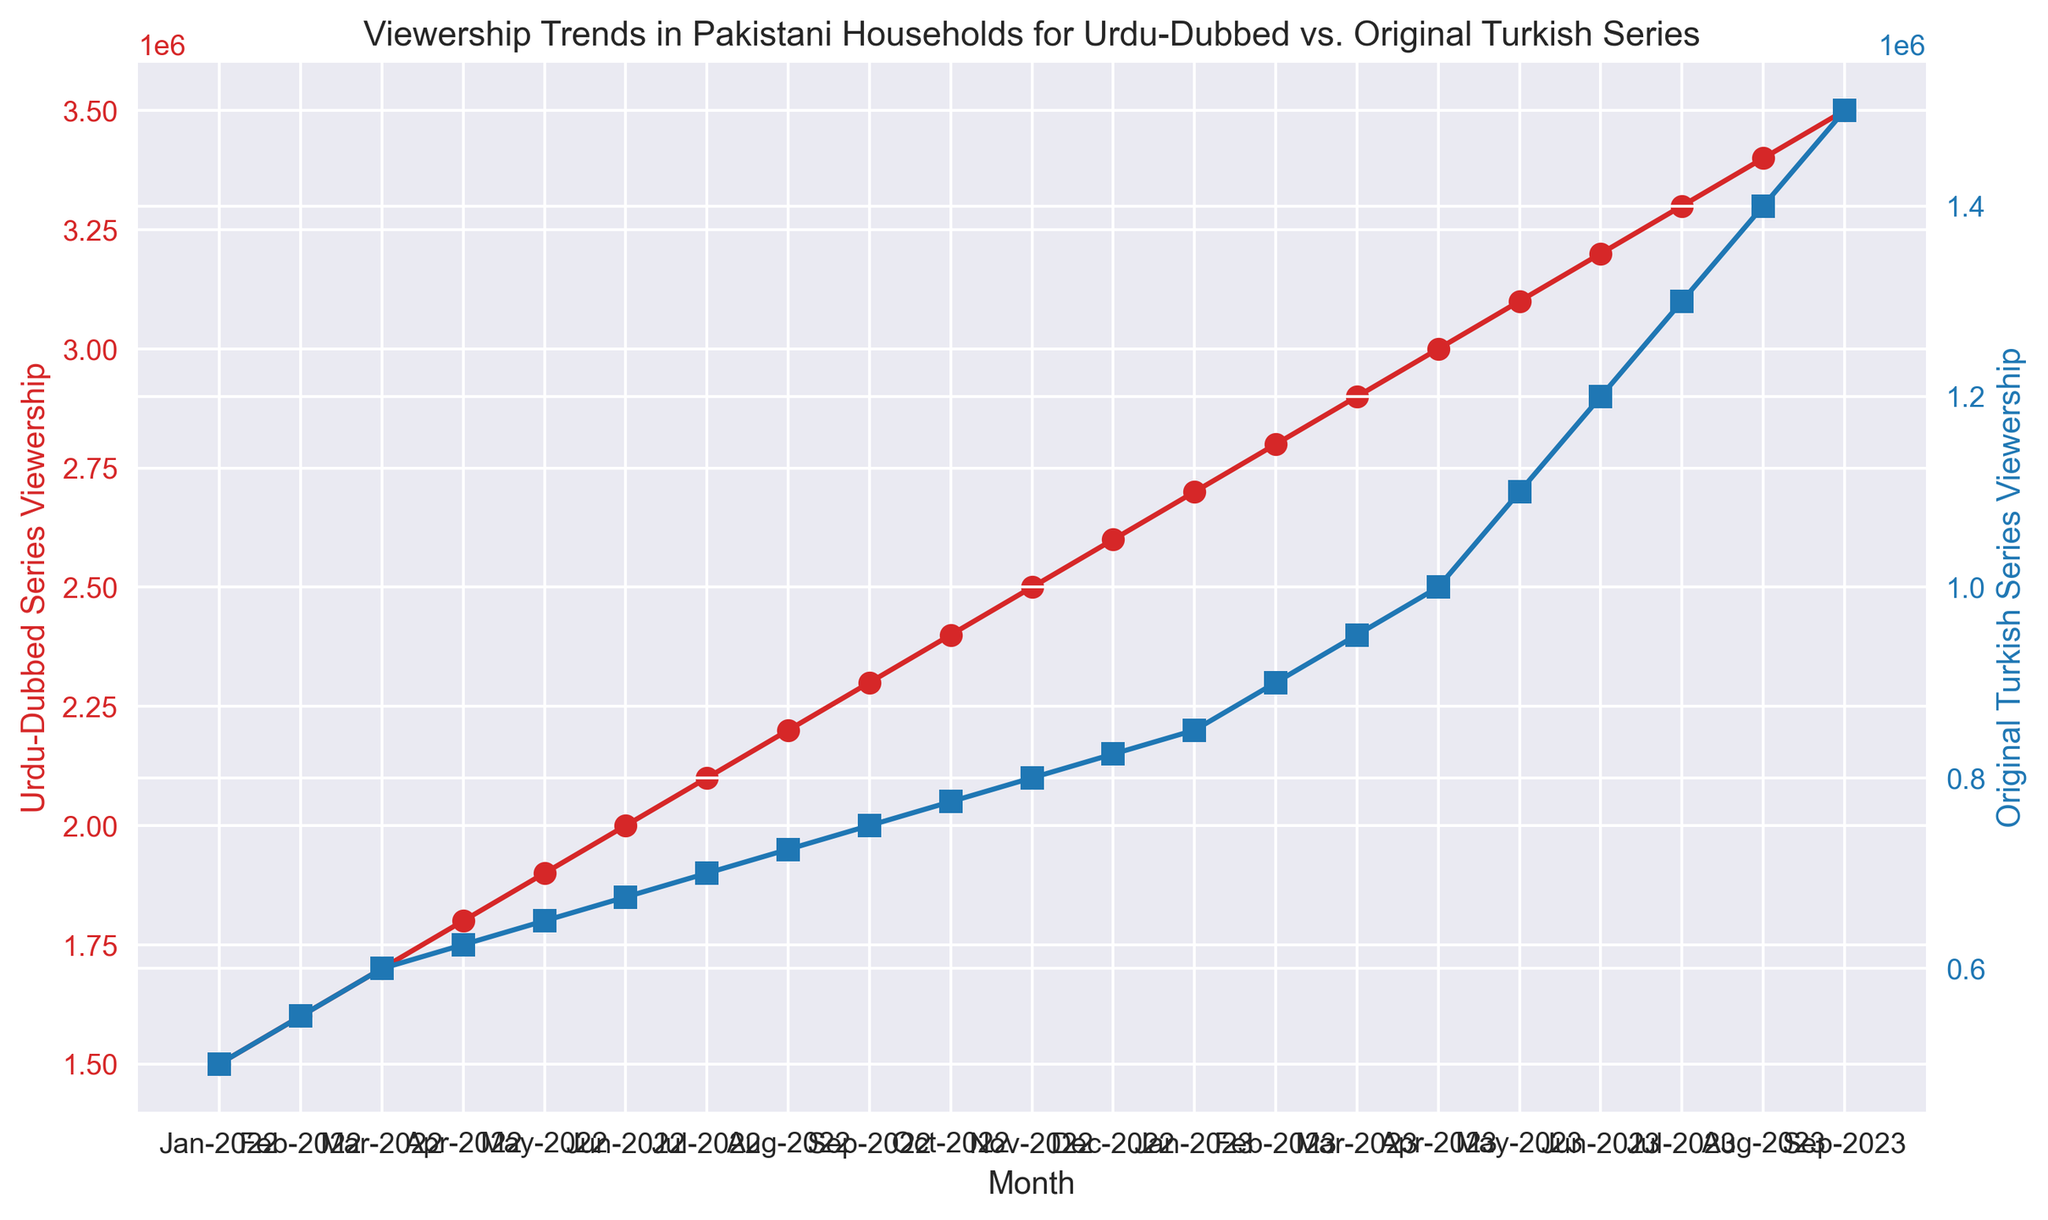Which month in 2022 had the highest viewership for Urdu-Dubbed Series? To find the month with the highest viewership for Urdu-Dubbed Series in 2022, we look at the data points from January 2022 to December 2022. December 2022 has the highest viewership with 2,600,000.
Answer: December 2022 In which month(s) does the Original Turkish Series viewership reach 1,000,000 or more? To determine the month(s) when the Original Turkish Series viewership reaches 1,000,000 or more, observe the data points from January 2022 to September 2023. April 2023 through September 2023 all have viewership of 1,000,000 or more.
Answer: April 2023 to September 2023 What is the total viewership for Urdu-Dubbed Series in the first half of 2022? Total viewership for the first half of 2022 includes data from January to June. Summing these values: 1,500,000 + 1,600,000 + 1,700,000 + 1,800,000 + 1,900,000 + 2,000,000 = 10,500,000.
Answer: 10,500,000 How does the viewership trend for Urdu-Dubbed Series compare to the trend for Original Turkish Series over the entire period? Observing both trends from January 2022 to September 2023, the Urdu-Dubbed Series consistently has higher viewership each month, but both series show an increasing trend over time. The gap between their viewership remains steady with the Urdu-Dubbed Series leading.
Answer: Urdu-Dubbed Series always higher; both trends increase By how much did the viewership of the Original Turkish Series increase from June 2023 to September 2023? To find the increase, subtract June 2023 viewership from September 2023 viewership: 1,500,000 (Sep 2023) - 1,200,000 (Jun 2023) = 300,000.
Answer: 300,000 Which series has the highest overall viewership, and in which month? From the data, Urdu-Dubbed Series in September 2023 has the highest overall viewership with 3,500,000.
Answer: Urdu-Dubbed Series in September 2023 What is the average monthly viewership of the Original Turkish Series from January 2022 to September 2023? To find the average, sum the viewership numbers for Original Turkish Series from Jan 2022 to Sep 2023 and divide by 21. The sum is 500,000 + 550,000 + 600,000 + 625,000 + 650,000 + 675,000 + 700,000 + 725,000 + 750,000 + 775,000 + 800,000 + 825,000 + 850,000 + 900,000 + 950,000 + 1,000,000 + 1,100,000 + 1,200,000 + 1,300,000 + 1,400,000 + 1,500,000 = 17,975,000. Divide by 21: 17,975,000 / 21 = 856,904.76.
Answer: ~856,905 At which point in time did both the Urdu-Dubbed Series and Original Turkish Series see the same amount of viewership increase over the previous month? Comparing month-over-month increases, both series have an increase of 100,000 viewership for each month in February, March, April, May, June, July, August, and September 2023.
Answer: February to September 2023 What was the viewership difference between the Urdu-Dubbed Series and Original Turkish Series in December 2022? To find the difference, subtract the viewership of Original Turkish Series from the Urdu-Dubbed Series in December 2022: 2,600,000 - 825,000 = 1,775,000.
Answer: 1,775,000 